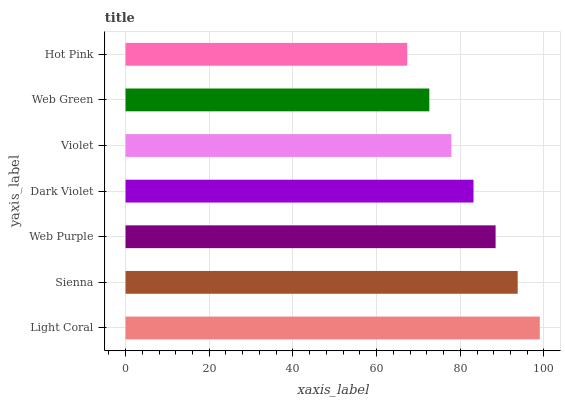Is Hot Pink the minimum?
Answer yes or no. Yes. Is Light Coral the maximum?
Answer yes or no. Yes. Is Sienna the minimum?
Answer yes or no. No. Is Sienna the maximum?
Answer yes or no. No. Is Light Coral greater than Sienna?
Answer yes or no. Yes. Is Sienna less than Light Coral?
Answer yes or no. Yes. Is Sienna greater than Light Coral?
Answer yes or no. No. Is Light Coral less than Sienna?
Answer yes or no. No. Is Dark Violet the high median?
Answer yes or no. Yes. Is Dark Violet the low median?
Answer yes or no. Yes. Is Web Purple the high median?
Answer yes or no. No. Is Web Green the low median?
Answer yes or no. No. 